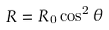<formula> <loc_0><loc_0><loc_500><loc_500>R = R _ { 0 } \cos ^ { 2 } \theta</formula> 